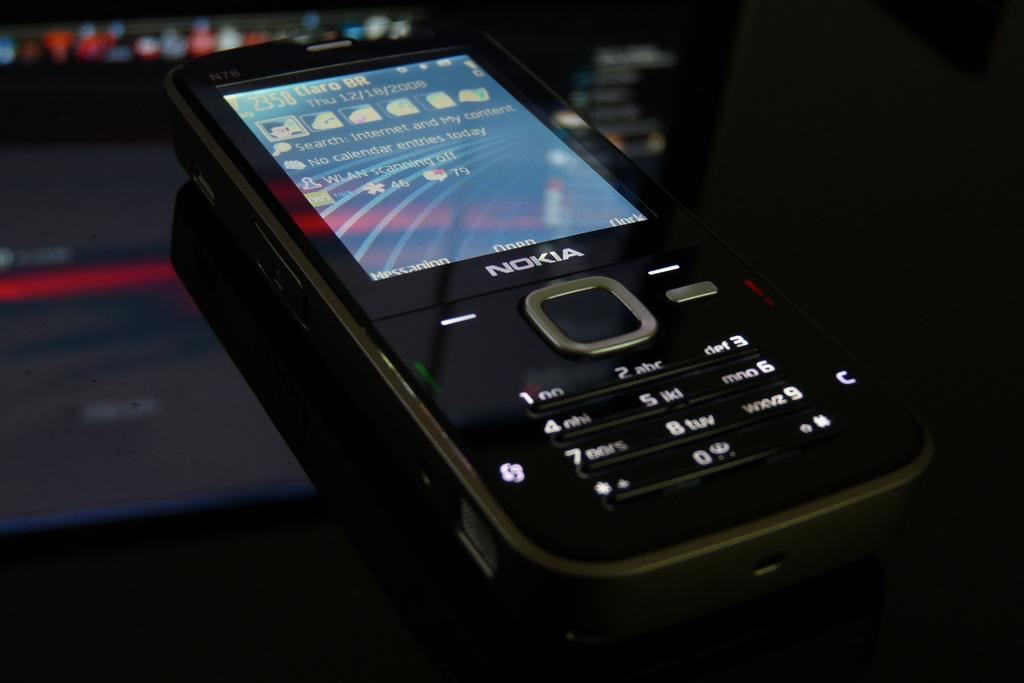<image>
Offer a succinct explanation of the picture presented. an old NOKIA phone in black with a lit up display 